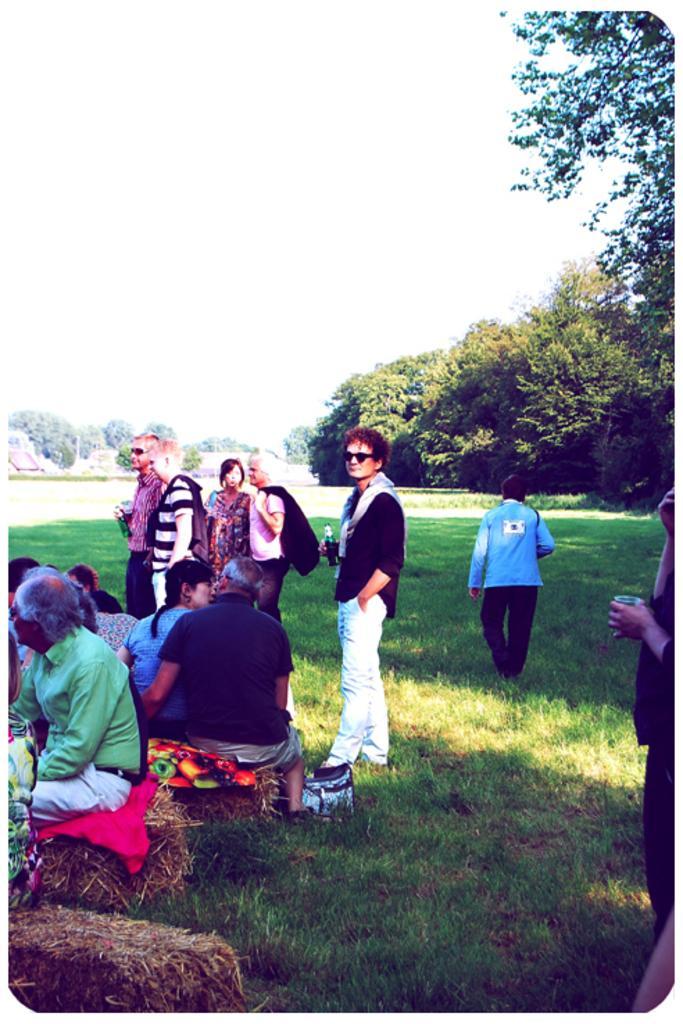In one or two sentences, can you explain what this image depicts? In this picture we can see the sky and it looks like a sunny day. We can see the trees, grass, objects and people. Few people are holding bottles in their hands. Few people are sitting. On the right side of the picture we can see the partial part of a person holding an object. 